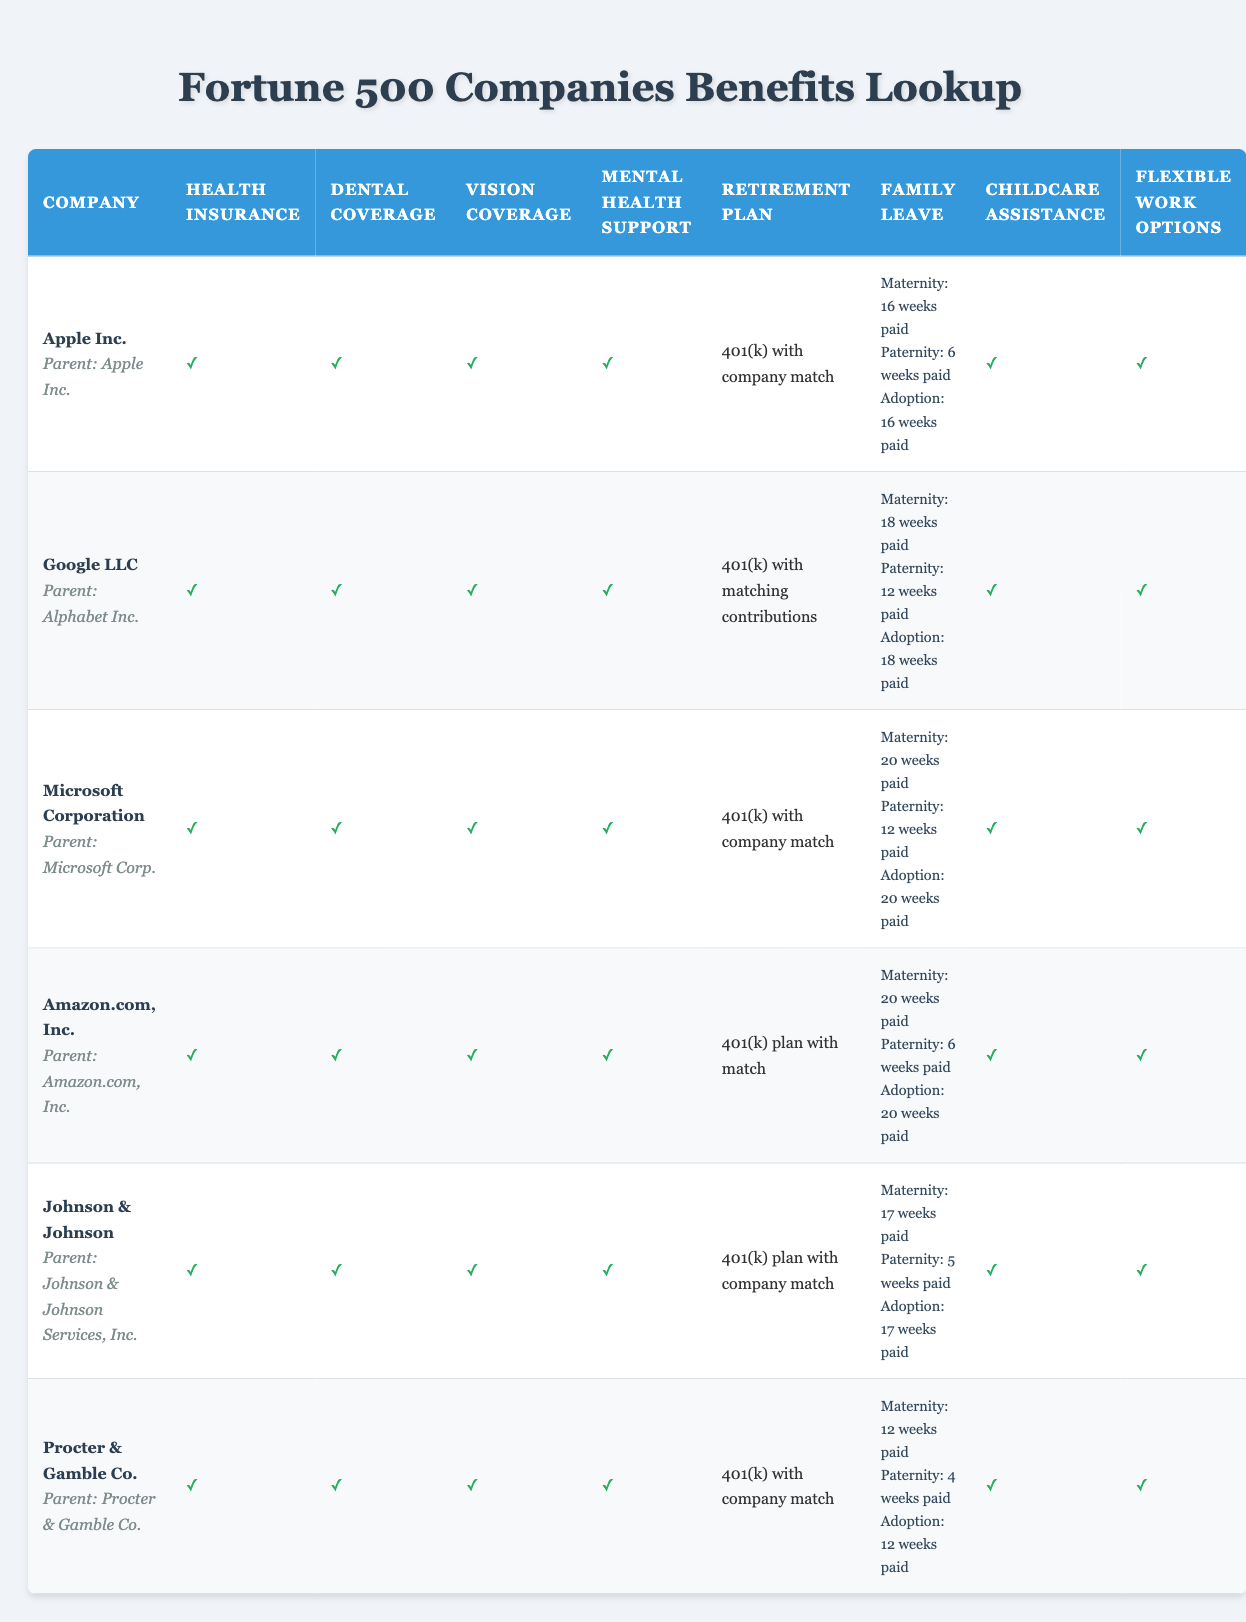What maternity leave does Google LLC offer? According to the table, Google LLC offers maternity leave for 18 weeks paid.
Answer: 18 weeks paid Which company offers the most weeks of paternity leave? By reviewing the paternity leave data from the table, Microsoft Corporation and Google LLC both offer the most at 12 weeks paid.
Answer: Microsoft Corporation and Google LLC (12 weeks paid) Is childcare assistance provided by Amazon.com, Inc.? The table shows that Amazon.com, Inc. does provide childcare assistance, indicated by a check mark.
Answer: Yes What is the average length of maternity leave offered by the seven companies listed? The maternity leave durations are 16, 18, 20, 20, 17, 12 weeks, and 12 weeks. Adding these gives 115 weeks, and dividing by 7 yields an average of approximately 16.43 weeks.
Answer: 16.43 weeks Does Johnson & Johnson offer flexible work options? The table indicates that Johnson & Johnson does provide flexible work options, as shown by a check mark.
Answer: Yes How many companies provide mental health support in their benefits? Upon counting the check marks in the mental health support column, all six companies listed offer this benefit.
Answer: 6 companies Which company has both the highest maternity leave and adoption leave policies? Examining the family leave policies reveals that Microsoft Corporation offers the highest maternity leave at 20 weeks and also matches that for adoption leave, making them the top for both.
Answer: Microsoft Corporation What percentage of companies have dental coverage as a benefit? All 7 companies have dental coverage (indicated by check marks), so the calculation is (7/7) * 100%, which equals 100%.
Answer: 100% Which companies have the same paternity leave duration? By reviewing the paternity leave data, both Google LLC and Microsoft Corporation offer 12 weeks paid, while Apple Inc. and Amazon.com, Inc. both provide 6 weeks paid. These two pairs are identified as having the same duration.
Answer: Google LLC and Microsoft Corporation (12 weeks); Apple Inc. and Amazon.com, Inc. (6 weeks) 